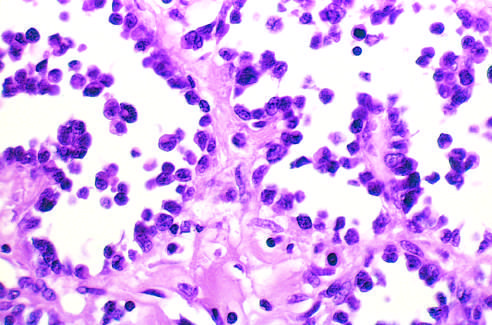what is lined by discohesive, uniform round tumor cells?
Answer the question using a single word or phrase. Alveolar rhabdomyosarcoma 